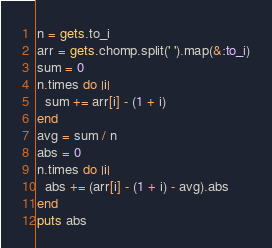<code> <loc_0><loc_0><loc_500><loc_500><_Ruby_>n = gets.to_i
arr = gets.chomp.split(' ').map(&:to_i)
sum = 0
n.times do |i|
  sum += arr[i] - (1 + i)
end
avg = sum / n
abs = 0
n.times do |i|
  abs += (arr[i] - (1 + i) - avg).abs
end
puts abs</code> 